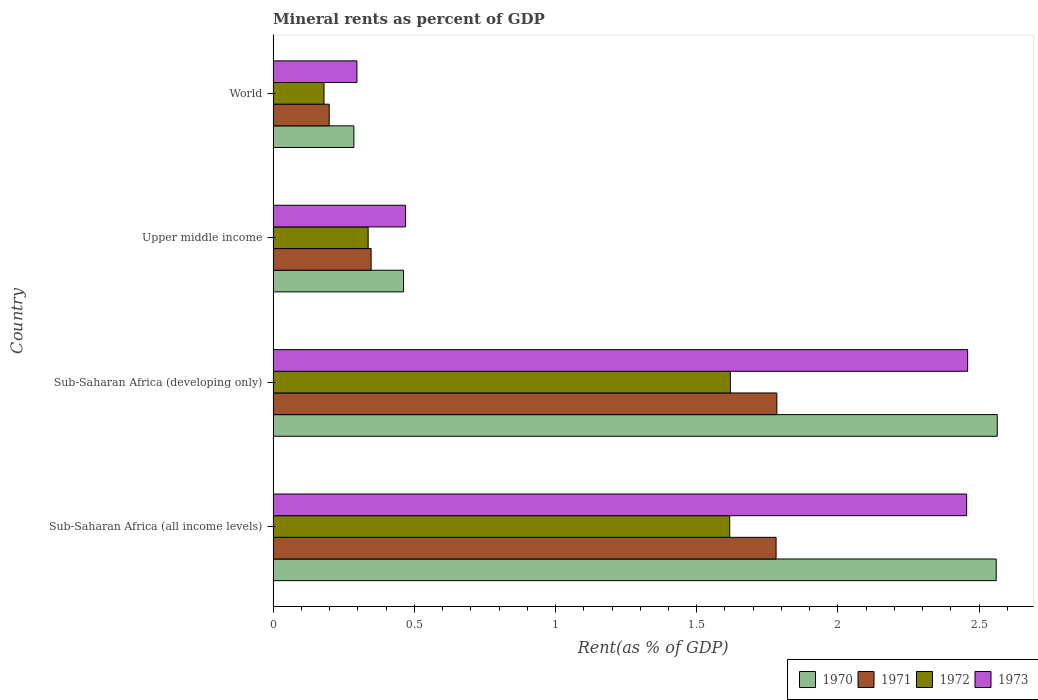How many bars are there on the 2nd tick from the bottom?
Offer a terse response. 4. What is the label of the 3rd group of bars from the top?
Ensure brevity in your answer.  Sub-Saharan Africa (developing only). What is the mineral rent in 1970 in Sub-Saharan Africa (developing only)?
Offer a terse response. 2.56. Across all countries, what is the maximum mineral rent in 1973?
Provide a short and direct response. 2.46. Across all countries, what is the minimum mineral rent in 1971?
Make the answer very short. 0.2. In which country was the mineral rent in 1972 maximum?
Offer a terse response. Sub-Saharan Africa (developing only). In which country was the mineral rent in 1971 minimum?
Your answer should be compact. World. What is the total mineral rent in 1970 in the graph?
Provide a short and direct response. 5.87. What is the difference between the mineral rent in 1973 in Sub-Saharan Africa (developing only) and that in Upper middle income?
Your answer should be very brief. 1.99. What is the difference between the mineral rent in 1972 in Sub-Saharan Africa (all income levels) and the mineral rent in 1971 in Upper middle income?
Your answer should be very brief. 1.27. What is the average mineral rent in 1970 per country?
Offer a very short reply. 1.47. What is the difference between the mineral rent in 1973 and mineral rent in 1972 in Sub-Saharan Africa (developing only)?
Offer a very short reply. 0.84. In how many countries, is the mineral rent in 1971 greater than 2.3 %?
Give a very brief answer. 0. What is the ratio of the mineral rent in 1970 in Upper middle income to that in World?
Make the answer very short. 1.62. Is the difference between the mineral rent in 1973 in Sub-Saharan Africa (all income levels) and World greater than the difference between the mineral rent in 1972 in Sub-Saharan Africa (all income levels) and World?
Make the answer very short. Yes. What is the difference between the highest and the second highest mineral rent in 1972?
Your answer should be very brief. 0. What is the difference between the highest and the lowest mineral rent in 1970?
Your answer should be compact. 2.28. In how many countries, is the mineral rent in 1970 greater than the average mineral rent in 1970 taken over all countries?
Provide a succinct answer. 2. What does the 2nd bar from the bottom in World represents?
Provide a short and direct response. 1971. Is it the case that in every country, the sum of the mineral rent in 1971 and mineral rent in 1972 is greater than the mineral rent in 1970?
Offer a very short reply. Yes. Are all the bars in the graph horizontal?
Provide a short and direct response. Yes. Are the values on the major ticks of X-axis written in scientific E-notation?
Your answer should be very brief. No. Does the graph contain grids?
Give a very brief answer. No. How many legend labels are there?
Ensure brevity in your answer.  4. What is the title of the graph?
Your answer should be compact. Mineral rents as percent of GDP. Does "1967" appear as one of the legend labels in the graph?
Keep it short and to the point. No. What is the label or title of the X-axis?
Your response must be concise. Rent(as % of GDP). What is the Rent(as % of GDP) in 1970 in Sub-Saharan Africa (all income levels)?
Give a very brief answer. 2.56. What is the Rent(as % of GDP) in 1971 in Sub-Saharan Africa (all income levels)?
Provide a succinct answer. 1.78. What is the Rent(as % of GDP) in 1972 in Sub-Saharan Africa (all income levels)?
Ensure brevity in your answer.  1.62. What is the Rent(as % of GDP) in 1973 in Sub-Saharan Africa (all income levels)?
Offer a terse response. 2.46. What is the Rent(as % of GDP) of 1970 in Sub-Saharan Africa (developing only)?
Provide a short and direct response. 2.56. What is the Rent(as % of GDP) of 1971 in Sub-Saharan Africa (developing only)?
Offer a terse response. 1.78. What is the Rent(as % of GDP) in 1972 in Sub-Saharan Africa (developing only)?
Ensure brevity in your answer.  1.62. What is the Rent(as % of GDP) of 1973 in Sub-Saharan Africa (developing only)?
Keep it short and to the point. 2.46. What is the Rent(as % of GDP) in 1970 in Upper middle income?
Provide a short and direct response. 0.46. What is the Rent(as % of GDP) in 1971 in Upper middle income?
Make the answer very short. 0.35. What is the Rent(as % of GDP) in 1972 in Upper middle income?
Keep it short and to the point. 0.34. What is the Rent(as % of GDP) in 1973 in Upper middle income?
Offer a terse response. 0.47. What is the Rent(as % of GDP) of 1970 in World?
Provide a short and direct response. 0.29. What is the Rent(as % of GDP) of 1971 in World?
Offer a very short reply. 0.2. What is the Rent(as % of GDP) in 1972 in World?
Your response must be concise. 0.18. What is the Rent(as % of GDP) of 1973 in World?
Offer a very short reply. 0.3. Across all countries, what is the maximum Rent(as % of GDP) in 1970?
Offer a terse response. 2.56. Across all countries, what is the maximum Rent(as % of GDP) of 1971?
Provide a short and direct response. 1.78. Across all countries, what is the maximum Rent(as % of GDP) of 1972?
Keep it short and to the point. 1.62. Across all countries, what is the maximum Rent(as % of GDP) in 1973?
Your response must be concise. 2.46. Across all countries, what is the minimum Rent(as % of GDP) of 1970?
Offer a very short reply. 0.29. Across all countries, what is the minimum Rent(as % of GDP) of 1971?
Provide a succinct answer. 0.2. Across all countries, what is the minimum Rent(as % of GDP) of 1972?
Provide a short and direct response. 0.18. Across all countries, what is the minimum Rent(as % of GDP) of 1973?
Ensure brevity in your answer.  0.3. What is the total Rent(as % of GDP) of 1970 in the graph?
Your answer should be very brief. 5.87. What is the total Rent(as % of GDP) of 1971 in the graph?
Provide a succinct answer. 4.11. What is the total Rent(as % of GDP) of 1972 in the graph?
Give a very brief answer. 3.75. What is the total Rent(as % of GDP) in 1973 in the graph?
Offer a terse response. 5.68. What is the difference between the Rent(as % of GDP) of 1970 in Sub-Saharan Africa (all income levels) and that in Sub-Saharan Africa (developing only)?
Give a very brief answer. -0. What is the difference between the Rent(as % of GDP) in 1971 in Sub-Saharan Africa (all income levels) and that in Sub-Saharan Africa (developing only)?
Offer a very short reply. -0. What is the difference between the Rent(as % of GDP) of 1972 in Sub-Saharan Africa (all income levels) and that in Sub-Saharan Africa (developing only)?
Your answer should be compact. -0. What is the difference between the Rent(as % of GDP) of 1973 in Sub-Saharan Africa (all income levels) and that in Sub-Saharan Africa (developing only)?
Make the answer very short. -0. What is the difference between the Rent(as % of GDP) of 1970 in Sub-Saharan Africa (all income levels) and that in Upper middle income?
Give a very brief answer. 2.1. What is the difference between the Rent(as % of GDP) of 1971 in Sub-Saharan Africa (all income levels) and that in Upper middle income?
Keep it short and to the point. 1.43. What is the difference between the Rent(as % of GDP) of 1972 in Sub-Saharan Africa (all income levels) and that in Upper middle income?
Provide a short and direct response. 1.28. What is the difference between the Rent(as % of GDP) of 1973 in Sub-Saharan Africa (all income levels) and that in Upper middle income?
Your response must be concise. 1.99. What is the difference between the Rent(as % of GDP) in 1970 in Sub-Saharan Africa (all income levels) and that in World?
Your response must be concise. 2.27. What is the difference between the Rent(as % of GDP) in 1971 in Sub-Saharan Africa (all income levels) and that in World?
Ensure brevity in your answer.  1.58. What is the difference between the Rent(as % of GDP) of 1972 in Sub-Saharan Africa (all income levels) and that in World?
Keep it short and to the point. 1.44. What is the difference between the Rent(as % of GDP) of 1973 in Sub-Saharan Africa (all income levels) and that in World?
Offer a very short reply. 2.16. What is the difference between the Rent(as % of GDP) of 1970 in Sub-Saharan Africa (developing only) and that in Upper middle income?
Your answer should be compact. 2.1. What is the difference between the Rent(as % of GDP) in 1971 in Sub-Saharan Africa (developing only) and that in Upper middle income?
Provide a short and direct response. 1.44. What is the difference between the Rent(as % of GDP) in 1972 in Sub-Saharan Africa (developing only) and that in Upper middle income?
Your answer should be compact. 1.28. What is the difference between the Rent(as % of GDP) of 1973 in Sub-Saharan Africa (developing only) and that in Upper middle income?
Provide a short and direct response. 1.99. What is the difference between the Rent(as % of GDP) of 1970 in Sub-Saharan Africa (developing only) and that in World?
Give a very brief answer. 2.28. What is the difference between the Rent(as % of GDP) in 1971 in Sub-Saharan Africa (developing only) and that in World?
Offer a very short reply. 1.58. What is the difference between the Rent(as % of GDP) of 1972 in Sub-Saharan Africa (developing only) and that in World?
Your answer should be compact. 1.44. What is the difference between the Rent(as % of GDP) of 1973 in Sub-Saharan Africa (developing only) and that in World?
Your response must be concise. 2.16. What is the difference between the Rent(as % of GDP) of 1970 in Upper middle income and that in World?
Offer a very short reply. 0.18. What is the difference between the Rent(as % of GDP) of 1971 in Upper middle income and that in World?
Offer a terse response. 0.15. What is the difference between the Rent(as % of GDP) in 1972 in Upper middle income and that in World?
Provide a short and direct response. 0.16. What is the difference between the Rent(as % of GDP) of 1973 in Upper middle income and that in World?
Offer a terse response. 0.17. What is the difference between the Rent(as % of GDP) of 1970 in Sub-Saharan Africa (all income levels) and the Rent(as % of GDP) of 1971 in Sub-Saharan Africa (developing only)?
Ensure brevity in your answer.  0.78. What is the difference between the Rent(as % of GDP) in 1970 in Sub-Saharan Africa (all income levels) and the Rent(as % of GDP) in 1973 in Sub-Saharan Africa (developing only)?
Provide a succinct answer. 0.1. What is the difference between the Rent(as % of GDP) of 1971 in Sub-Saharan Africa (all income levels) and the Rent(as % of GDP) of 1972 in Sub-Saharan Africa (developing only)?
Make the answer very short. 0.16. What is the difference between the Rent(as % of GDP) in 1971 in Sub-Saharan Africa (all income levels) and the Rent(as % of GDP) in 1973 in Sub-Saharan Africa (developing only)?
Give a very brief answer. -0.68. What is the difference between the Rent(as % of GDP) in 1972 in Sub-Saharan Africa (all income levels) and the Rent(as % of GDP) in 1973 in Sub-Saharan Africa (developing only)?
Provide a short and direct response. -0.84. What is the difference between the Rent(as % of GDP) of 1970 in Sub-Saharan Africa (all income levels) and the Rent(as % of GDP) of 1971 in Upper middle income?
Your answer should be very brief. 2.21. What is the difference between the Rent(as % of GDP) in 1970 in Sub-Saharan Africa (all income levels) and the Rent(as % of GDP) in 1972 in Upper middle income?
Make the answer very short. 2.22. What is the difference between the Rent(as % of GDP) of 1970 in Sub-Saharan Africa (all income levels) and the Rent(as % of GDP) of 1973 in Upper middle income?
Ensure brevity in your answer.  2.09. What is the difference between the Rent(as % of GDP) in 1971 in Sub-Saharan Africa (all income levels) and the Rent(as % of GDP) in 1972 in Upper middle income?
Keep it short and to the point. 1.44. What is the difference between the Rent(as % of GDP) of 1971 in Sub-Saharan Africa (all income levels) and the Rent(as % of GDP) of 1973 in Upper middle income?
Offer a very short reply. 1.31. What is the difference between the Rent(as % of GDP) of 1972 in Sub-Saharan Africa (all income levels) and the Rent(as % of GDP) of 1973 in Upper middle income?
Provide a short and direct response. 1.15. What is the difference between the Rent(as % of GDP) of 1970 in Sub-Saharan Africa (all income levels) and the Rent(as % of GDP) of 1971 in World?
Keep it short and to the point. 2.36. What is the difference between the Rent(as % of GDP) of 1970 in Sub-Saharan Africa (all income levels) and the Rent(as % of GDP) of 1972 in World?
Your response must be concise. 2.38. What is the difference between the Rent(as % of GDP) of 1970 in Sub-Saharan Africa (all income levels) and the Rent(as % of GDP) of 1973 in World?
Offer a terse response. 2.26. What is the difference between the Rent(as % of GDP) in 1971 in Sub-Saharan Africa (all income levels) and the Rent(as % of GDP) in 1972 in World?
Give a very brief answer. 1.6. What is the difference between the Rent(as % of GDP) of 1971 in Sub-Saharan Africa (all income levels) and the Rent(as % of GDP) of 1973 in World?
Provide a succinct answer. 1.48. What is the difference between the Rent(as % of GDP) in 1972 in Sub-Saharan Africa (all income levels) and the Rent(as % of GDP) in 1973 in World?
Your response must be concise. 1.32. What is the difference between the Rent(as % of GDP) of 1970 in Sub-Saharan Africa (developing only) and the Rent(as % of GDP) of 1971 in Upper middle income?
Offer a very short reply. 2.22. What is the difference between the Rent(as % of GDP) in 1970 in Sub-Saharan Africa (developing only) and the Rent(as % of GDP) in 1972 in Upper middle income?
Offer a very short reply. 2.23. What is the difference between the Rent(as % of GDP) of 1970 in Sub-Saharan Africa (developing only) and the Rent(as % of GDP) of 1973 in Upper middle income?
Keep it short and to the point. 2.1. What is the difference between the Rent(as % of GDP) of 1971 in Sub-Saharan Africa (developing only) and the Rent(as % of GDP) of 1972 in Upper middle income?
Make the answer very short. 1.45. What is the difference between the Rent(as % of GDP) in 1971 in Sub-Saharan Africa (developing only) and the Rent(as % of GDP) in 1973 in Upper middle income?
Ensure brevity in your answer.  1.31. What is the difference between the Rent(as % of GDP) of 1972 in Sub-Saharan Africa (developing only) and the Rent(as % of GDP) of 1973 in Upper middle income?
Give a very brief answer. 1.15. What is the difference between the Rent(as % of GDP) in 1970 in Sub-Saharan Africa (developing only) and the Rent(as % of GDP) in 1971 in World?
Give a very brief answer. 2.37. What is the difference between the Rent(as % of GDP) of 1970 in Sub-Saharan Africa (developing only) and the Rent(as % of GDP) of 1972 in World?
Make the answer very short. 2.38. What is the difference between the Rent(as % of GDP) of 1970 in Sub-Saharan Africa (developing only) and the Rent(as % of GDP) of 1973 in World?
Keep it short and to the point. 2.27. What is the difference between the Rent(as % of GDP) in 1971 in Sub-Saharan Africa (developing only) and the Rent(as % of GDP) in 1972 in World?
Provide a succinct answer. 1.6. What is the difference between the Rent(as % of GDP) of 1971 in Sub-Saharan Africa (developing only) and the Rent(as % of GDP) of 1973 in World?
Give a very brief answer. 1.49. What is the difference between the Rent(as % of GDP) of 1972 in Sub-Saharan Africa (developing only) and the Rent(as % of GDP) of 1973 in World?
Give a very brief answer. 1.32. What is the difference between the Rent(as % of GDP) of 1970 in Upper middle income and the Rent(as % of GDP) of 1971 in World?
Ensure brevity in your answer.  0.26. What is the difference between the Rent(as % of GDP) in 1970 in Upper middle income and the Rent(as % of GDP) in 1972 in World?
Make the answer very short. 0.28. What is the difference between the Rent(as % of GDP) of 1970 in Upper middle income and the Rent(as % of GDP) of 1973 in World?
Offer a terse response. 0.17. What is the difference between the Rent(as % of GDP) in 1971 in Upper middle income and the Rent(as % of GDP) in 1973 in World?
Provide a succinct answer. 0.05. What is the difference between the Rent(as % of GDP) of 1972 in Upper middle income and the Rent(as % of GDP) of 1973 in World?
Offer a very short reply. 0.04. What is the average Rent(as % of GDP) in 1970 per country?
Make the answer very short. 1.47. What is the average Rent(as % of GDP) in 1971 per country?
Offer a terse response. 1.03. What is the average Rent(as % of GDP) of 1972 per country?
Offer a terse response. 0.94. What is the average Rent(as % of GDP) in 1973 per country?
Ensure brevity in your answer.  1.42. What is the difference between the Rent(as % of GDP) of 1970 and Rent(as % of GDP) of 1971 in Sub-Saharan Africa (all income levels)?
Your response must be concise. 0.78. What is the difference between the Rent(as % of GDP) in 1970 and Rent(as % of GDP) in 1972 in Sub-Saharan Africa (all income levels)?
Make the answer very short. 0.94. What is the difference between the Rent(as % of GDP) in 1970 and Rent(as % of GDP) in 1973 in Sub-Saharan Africa (all income levels)?
Offer a very short reply. 0.1. What is the difference between the Rent(as % of GDP) in 1971 and Rent(as % of GDP) in 1972 in Sub-Saharan Africa (all income levels)?
Provide a succinct answer. 0.16. What is the difference between the Rent(as % of GDP) in 1971 and Rent(as % of GDP) in 1973 in Sub-Saharan Africa (all income levels)?
Provide a succinct answer. -0.67. What is the difference between the Rent(as % of GDP) in 1972 and Rent(as % of GDP) in 1973 in Sub-Saharan Africa (all income levels)?
Ensure brevity in your answer.  -0.84. What is the difference between the Rent(as % of GDP) of 1970 and Rent(as % of GDP) of 1971 in Sub-Saharan Africa (developing only)?
Offer a terse response. 0.78. What is the difference between the Rent(as % of GDP) in 1970 and Rent(as % of GDP) in 1972 in Sub-Saharan Africa (developing only)?
Provide a short and direct response. 0.95. What is the difference between the Rent(as % of GDP) of 1970 and Rent(as % of GDP) of 1973 in Sub-Saharan Africa (developing only)?
Your answer should be compact. 0.1. What is the difference between the Rent(as % of GDP) of 1971 and Rent(as % of GDP) of 1972 in Sub-Saharan Africa (developing only)?
Your response must be concise. 0.16. What is the difference between the Rent(as % of GDP) in 1971 and Rent(as % of GDP) in 1973 in Sub-Saharan Africa (developing only)?
Offer a terse response. -0.68. What is the difference between the Rent(as % of GDP) of 1972 and Rent(as % of GDP) of 1973 in Sub-Saharan Africa (developing only)?
Keep it short and to the point. -0.84. What is the difference between the Rent(as % of GDP) of 1970 and Rent(as % of GDP) of 1971 in Upper middle income?
Give a very brief answer. 0.11. What is the difference between the Rent(as % of GDP) of 1970 and Rent(as % of GDP) of 1972 in Upper middle income?
Give a very brief answer. 0.13. What is the difference between the Rent(as % of GDP) of 1970 and Rent(as % of GDP) of 1973 in Upper middle income?
Your answer should be compact. -0.01. What is the difference between the Rent(as % of GDP) in 1971 and Rent(as % of GDP) in 1972 in Upper middle income?
Your answer should be very brief. 0.01. What is the difference between the Rent(as % of GDP) in 1971 and Rent(as % of GDP) in 1973 in Upper middle income?
Make the answer very short. -0.12. What is the difference between the Rent(as % of GDP) of 1972 and Rent(as % of GDP) of 1973 in Upper middle income?
Offer a terse response. -0.13. What is the difference between the Rent(as % of GDP) in 1970 and Rent(as % of GDP) in 1971 in World?
Provide a succinct answer. 0.09. What is the difference between the Rent(as % of GDP) in 1970 and Rent(as % of GDP) in 1972 in World?
Your response must be concise. 0.11. What is the difference between the Rent(as % of GDP) of 1970 and Rent(as % of GDP) of 1973 in World?
Offer a terse response. -0.01. What is the difference between the Rent(as % of GDP) in 1971 and Rent(as % of GDP) in 1972 in World?
Offer a terse response. 0.02. What is the difference between the Rent(as % of GDP) in 1971 and Rent(as % of GDP) in 1973 in World?
Offer a very short reply. -0.1. What is the difference between the Rent(as % of GDP) of 1972 and Rent(as % of GDP) of 1973 in World?
Give a very brief answer. -0.12. What is the ratio of the Rent(as % of GDP) in 1970 in Sub-Saharan Africa (all income levels) to that in Sub-Saharan Africa (developing only)?
Make the answer very short. 1. What is the ratio of the Rent(as % of GDP) in 1970 in Sub-Saharan Africa (all income levels) to that in Upper middle income?
Your response must be concise. 5.54. What is the ratio of the Rent(as % of GDP) in 1971 in Sub-Saharan Africa (all income levels) to that in Upper middle income?
Give a very brief answer. 5.13. What is the ratio of the Rent(as % of GDP) of 1972 in Sub-Saharan Africa (all income levels) to that in Upper middle income?
Keep it short and to the point. 4.81. What is the ratio of the Rent(as % of GDP) of 1973 in Sub-Saharan Africa (all income levels) to that in Upper middle income?
Ensure brevity in your answer.  5.24. What is the ratio of the Rent(as % of GDP) of 1970 in Sub-Saharan Africa (all income levels) to that in World?
Ensure brevity in your answer.  8.95. What is the ratio of the Rent(as % of GDP) in 1971 in Sub-Saharan Africa (all income levels) to that in World?
Offer a very short reply. 8.97. What is the ratio of the Rent(as % of GDP) in 1972 in Sub-Saharan Africa (all income levels) to that in World?
Offer a terse response. 8.97. What is the ratio of the Rent(as % of GDP) in 1973 in Sub-Saharan Africa (all income levels) to that in World?
Provide a succinct answer. 8.28. What is the ratio of the Rent(as % of GDP) of 1970 in Sub-Saharan Africa (developing only) to that in Upper middle income?
Your answer should be very brief. 5.55. What is the ratio of the Rent(as % of GDP) in 1971 in Sub-Saharan Africa (developing only) to that in Upper middle income?
Provide a short and direct response. 5.14. What is the ratio of the Rent(as % of GDP) of 1972 in Sub-Saharan Africa (developing only) to that in Upper middle income?
Keep it short and to the point. 4.81. What is the ratio of the Rent(as % of GDP) of 1973 in Sub-Saharan Africa (developing only) to that in Upper middle income?
Ensure brevity in your answer.  5.24. What is the ratio of the Rent(as % of GDP) of 1970 in Sub-Saharan Africa (developing only) to that in World?
Make the answer very short. 8.97. What is the ratio of the Rent(as % of GDP) in 1971 in Sub-Saharan Africa (developing only) to that in World?
Your answer should be very brief. 8.98. What is the ratio of the Rent(as % of GDP) in 1972 in Sub-Saharan Africa (developing only) to that in World?
Provide a succinct answer. 8.98. What is the ratio of the Rent(as % of GDP) of 1973 in Sub-Saharan Africa (developing only) to that in World?
Give a very brief answer. 8.29. What is the ratio of the Rent(as % of GDP) in 1970 in Upper middle income to that in World?
Offer a terse response. 1.62. What is the ratio of the Rent(as % of GDP) in 1971 in Upper middle income to that in World?
Provide a succinct answer. 1.75. What is the ratio of the Rent(as % of GDP) in 1972 in Upper middle income to that in World?
Offer a terse response. 1.87. What is the ratio of the Rent(as % of GDP) of 1973 in Upper middle income to that in World?
Your answer should be compact. 1.58. What is the difference between the highest and the second highest Rent(as % of GDP) of 1970?
Give a very brief answer. 0. What is the difference between the highest and the second highest Rent(as % of GDP) of 1971?
Provide a short and direct response. 0. What is the difference between the highest and the second highest Rent(as % of GDP) of 1972?
Your answer should be compact. 0. What is the difference between the highest and the second highest Rent(as % of GDP) of 1973?
Provide a short and direct response. 0. What is the difference between the highest and the lowest Rent(as % of GDP) in 1970?
Keep it short and to the point. 2.28. What is the difference between the highest and the lowest Rent(as % of GDP) in 1971?
Offer a terse response. 1.58. What is the difference between the highest and the lowest Rent(as % of GDP) in 1972?
Make the answer very short. 1.44. What is the difference between the highest and the lowest Rent(as % of GDP) of 1973?
Your response must be concise. 2.16. 